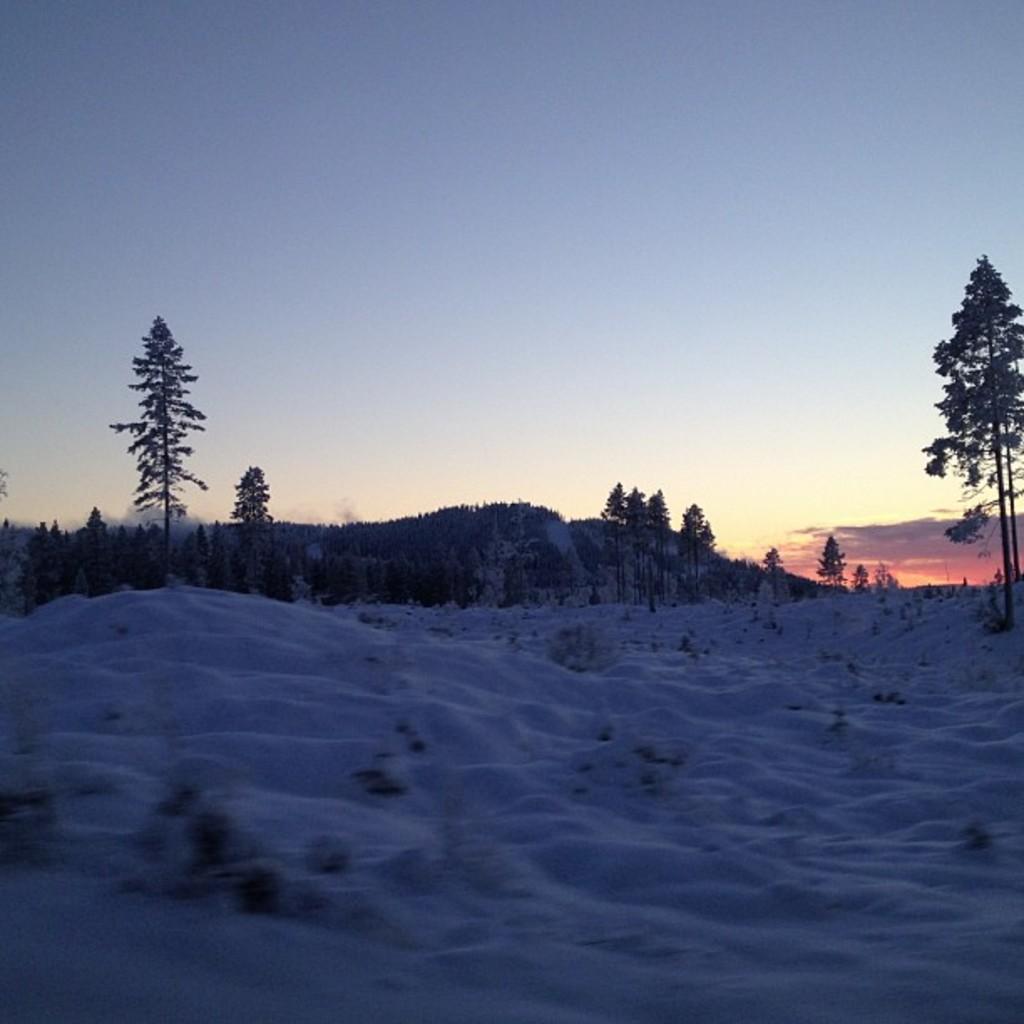Could you give a brief overview of what you see in this image? Here we can see a sunset picture with a beautiful scenery. There are trees. There is snow everywhere. 